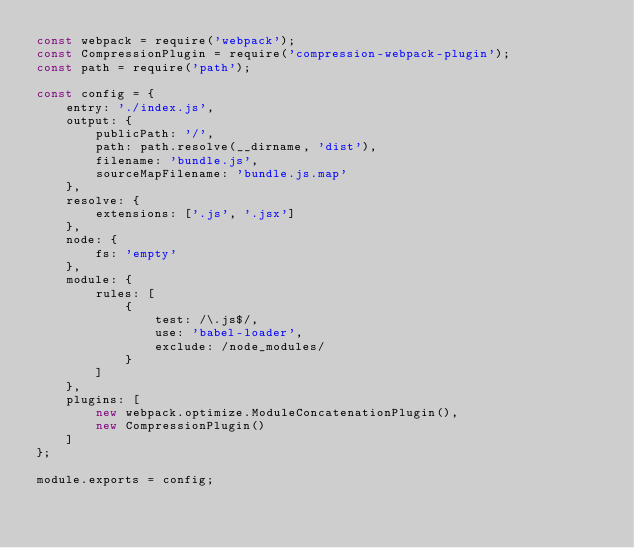Convert code to text. <code><loc_0><loc_0><loc_500><loc_500><_JavaScript_>const webpack = require('webpack');
const CompressionPlugin = require('compression-webpack-plugin');
const path = require('path');

const config = {
    entry: './index.js',
    output: {
        publicPath: '/',
        path: path.resolve(__dirname, 'dist'),
        filename: 'bundle.js',
        sourceMapFilename: 'bundle.js.map'
    },
    resolve: {
        extensions: ['.js', '.jsx']
    },
    node: {
        fs: 'empty'
    },
    module: {
        rules: [
            {
                test: /\.js$/,
                use: 'babel-loader',
                exclude: /node_modules/
            }
        ]
    },
    plugins: [
        new webpack.optimize.ModuleConcatenationPlugin(),
        new CompressionPlugin()
    ]
};

module.exports = config;
</code> 